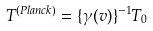<formula> <loc_0><loc_0><loc_500><loc_500>T ^ { ( P l a n c k ) } = \{ \gamma ( v ) \} ^ { - 1 } T _ { 0 }</formula> 